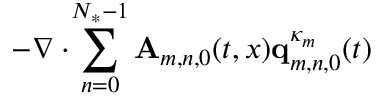<formula> <loc_0><loc_0><loc_500><loc_500>\begin{array} { r l } { { - \nabla \cdot \, \sum _ { n = 0 } ^ { N _ { * } - 1 } A _ { m , n , 0 } ( t , x ) q _ { m , n , 0 } ^ { \kappa _ { m } } ( t ) } \quad } \end{array}</formula> 